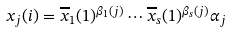Convert formula to latex. <formula><loc_0><loc_0><loc_500><loc_500>x _ { j } ( i ) = \overline { x } _ { 1 } ( 1 ) ^ { \beta _ { 1 } ( j ) } \cdots \overline { x } _ { s } ( 1 ) ^ { \beta _ { s } ( j ) } \alpha _ { j }</formula> 